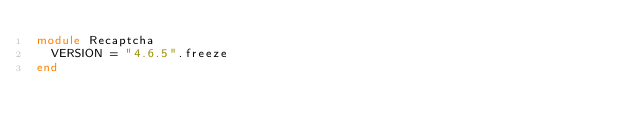Convert code to text. <code><loc_0><loc_0><loc_500><loc_500><_Ruby_>module Recaptcha
  VERSION = "4.6.5".freeze
end
</code> 